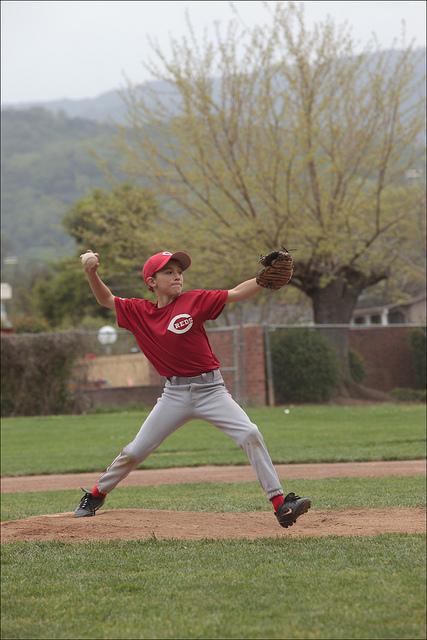What popular teams Jersey does his shirt closely resemble?
Concise answer only. Reds. What is the boy doing?
Be succinct. Pitching. What is the boy throwing?
Answer briefly. Baseball. 